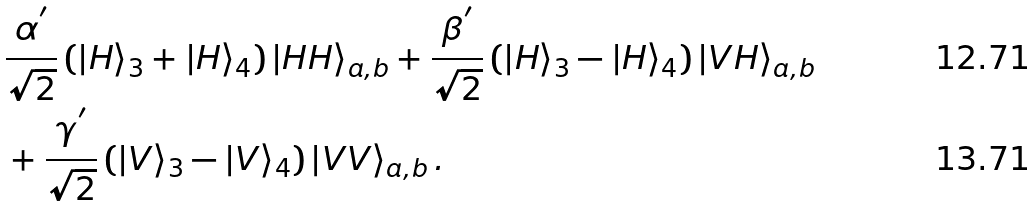Convert formula to latex. <formula><loc_0><loc_0><loc_500><loc_500>& \frac { \alpha ^ { ^ { \prime } } } { \sqrt { 2 } } \left ( \left | H \right \rangle _ { 3 } + \left | H \right \rangle _ { 4 } \right ) \left | H H \right \rangle _ { a , b } + \frac { \beta ^ { ^ { \prime } } } { \sqrt { 2 } } \left ( \left | H \right \rangle _ { 3 } - \left | H \right \rangle _ { 4 } \right ) \left | V H \right \rangle _ { a , b } \\ & + \frac { \gamma ^ { ^ { \prime } } } { \sqrt { 2 } } \left ( \left | V \right \rangle _ { 3 } - \left | V \right \rangle _ { 4 } \right ) \left | V V \right \rangle _ { a , b } .</formula> 